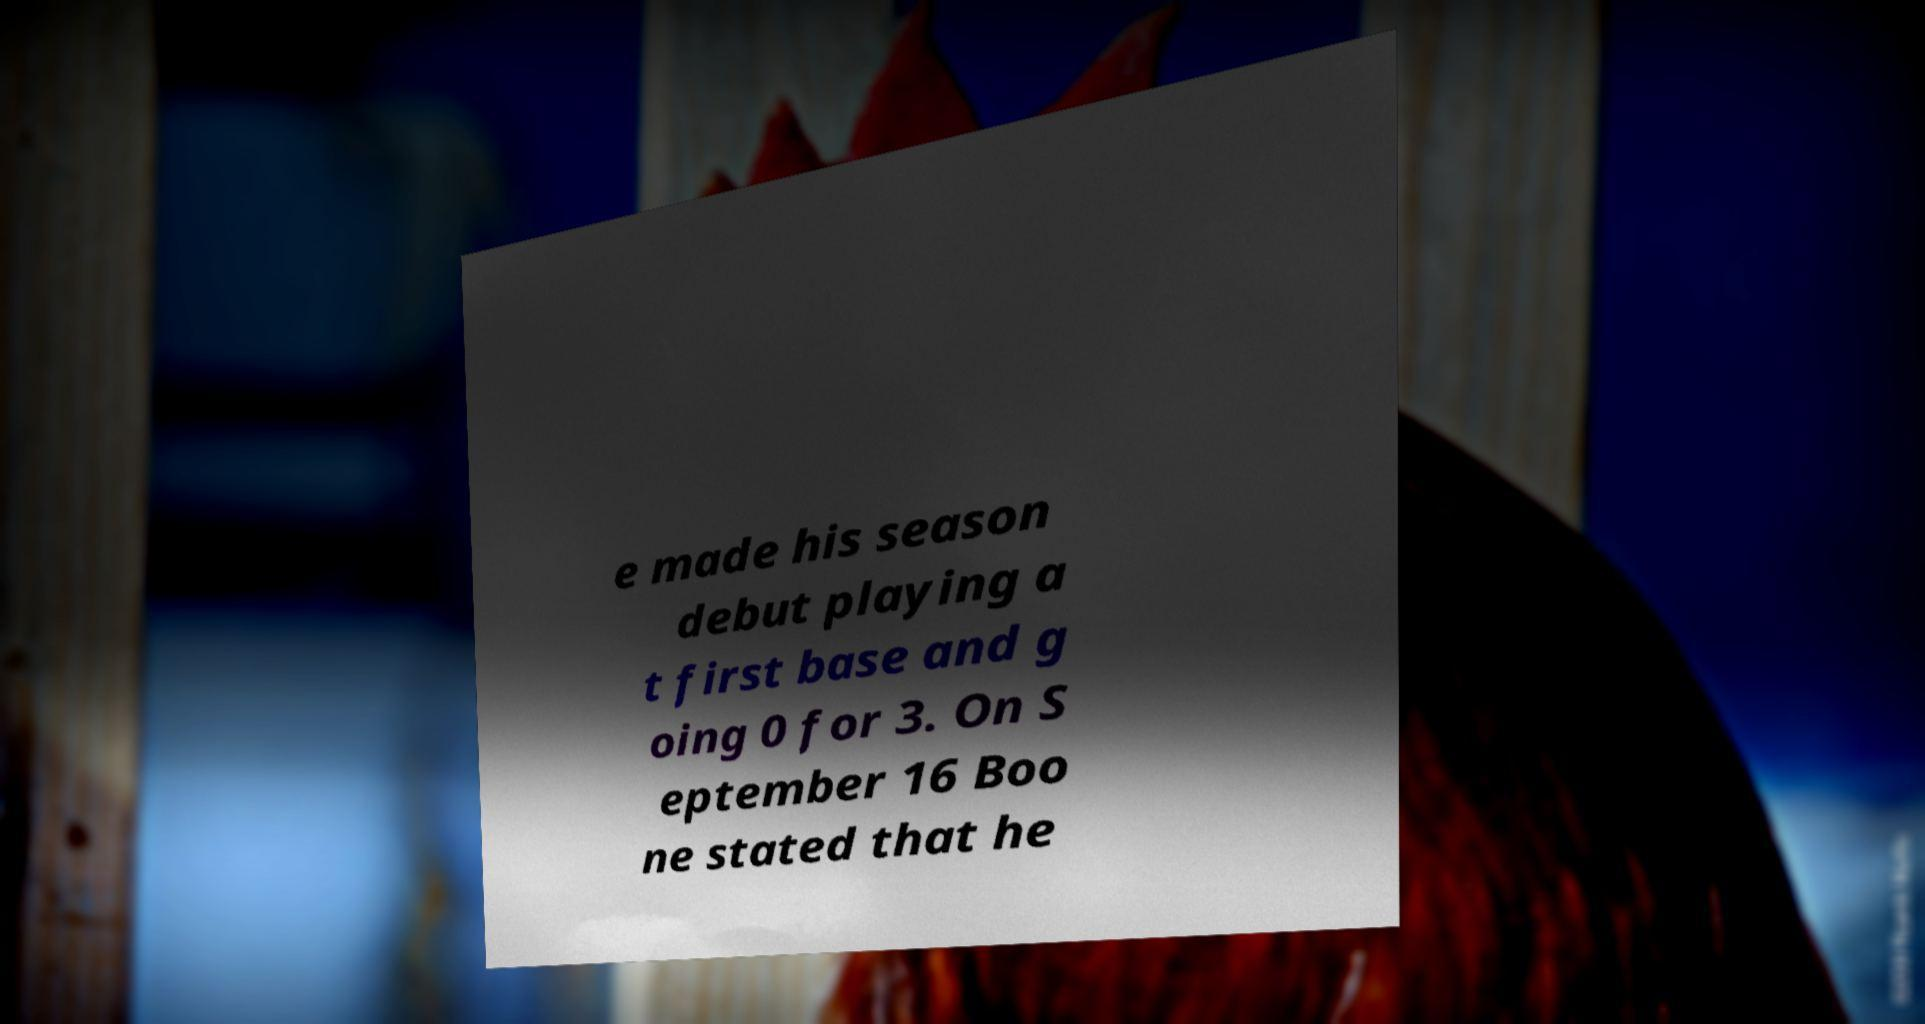Could you extract and type out the text from this image? e made his season debut playing a t first base and g oing 0 for 3. On S eptember 16 Boo ne stated that he 